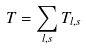Convert formula to latex. <formula><loc_0><loc_0><loc_500><loc_500>T = \sum _ { l , s } T _ { l , s }</formula> 